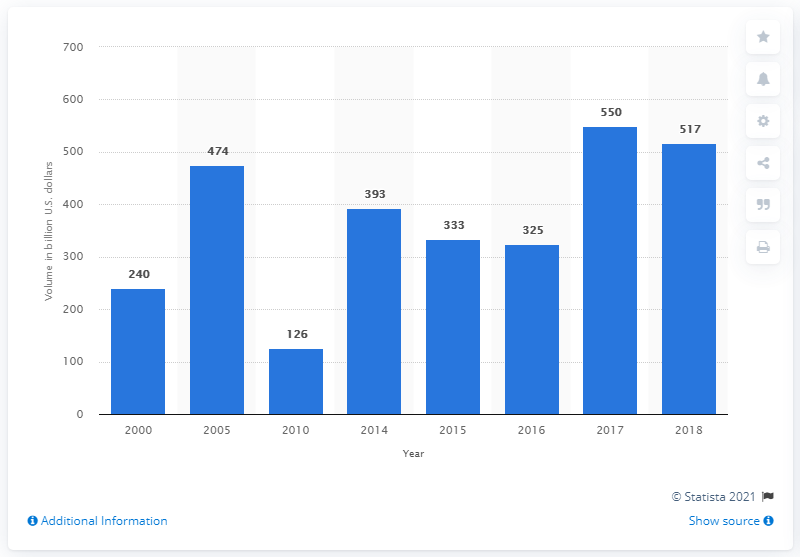Give some essential details in this illustration. The new issue volume of asset-backed securities in the United States in 2018 was approximately 517. 